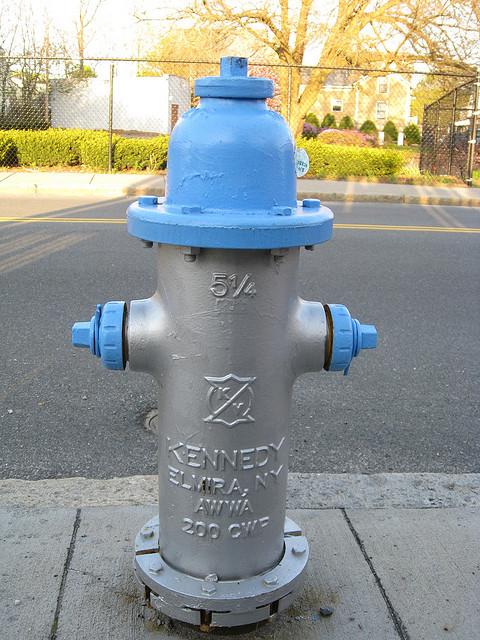What city is on the hydrant?
Write a very short answer. Elmira. Could someone untwist the fire hydrant by hand?
Answer briefly. No. What two colors are on the fire hydrant?
Be succinct. Blue and silver. Is this city clean?
Concise answer only. Yes. 